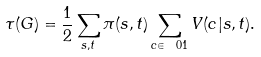<formula> <loc_0><loc_0><loc_500><loc_500>\tau ( G ) = \frac { 1 } { 2 } \sum _ { s , t } \pi ( s , t ) \sum _ { c \in \ 0 1 } V ( c | s , t ) .</formula> 